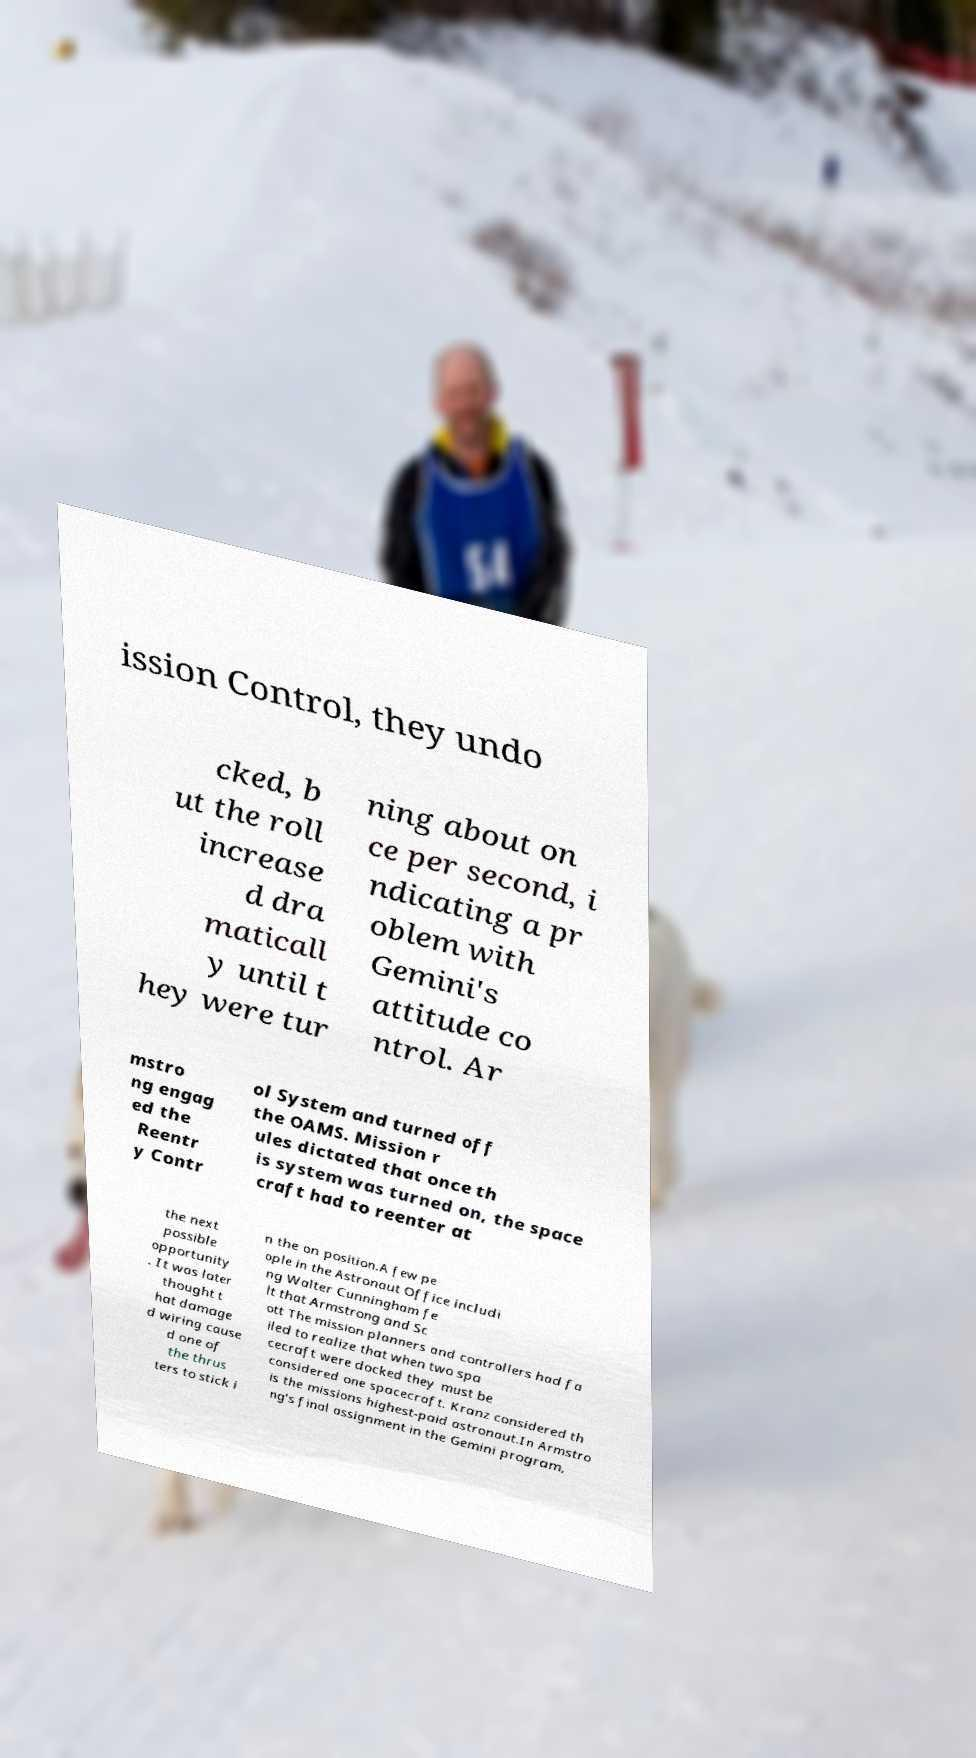For documentation purposes, I need the text within this image transcribed. Could you provide that? ission Control, they undo cked, b ut the roll increase d dra maticall y until t hey were tur ning about on ce per second, i ndicating a pr oblem with Gemini's attitude co ntrol. Ar mstro ng engag ed the Reentr y Contr ol System and turned off the OAMS. Mission r ules dictated that once th is system was turned on, the space craft had to reenter at the next possible opportunity . It was later thought t hat damage d wiring cause d one of the thrus ters to stick i n the on position.A few pe ople in the Astronaut Office includi ng Walter Cunningham fe lt that Armstrong and Sc ott The mission planners and controllers had fa iled to realize that when two spa cecraft were docked they must be considered one spacecraft. Kranz considered th is the missions highest-paid astronaut.In Armstro ng's final assignment in the Gemini program, 